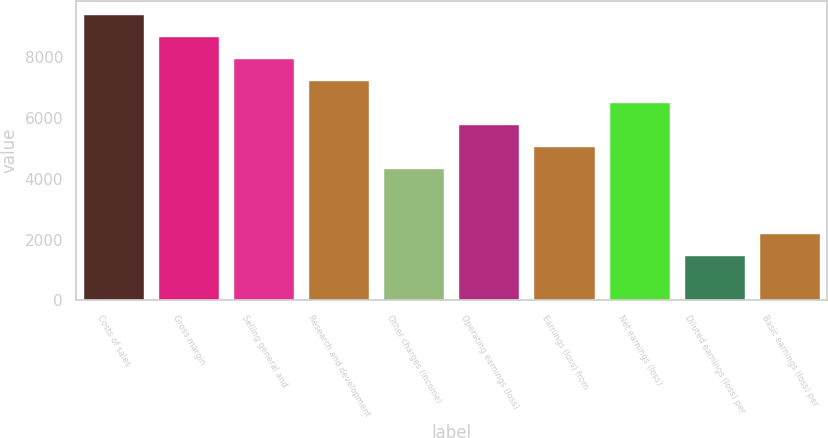<chart> <loc_0><loc_0><loc_500><loc_500><bar_chart><fcel>Costs of sales<fcel>Gross margin<fcel>Selling general and<fcel>Research and development<fcel>Other charges (income)<fcel>Operating earnings (loss)<fcel>Earnings (loss) from<fcel>Net earnings (loss)<fcel>Diluted earnings (loss) per<fcel>Basic earnings (loss) per<nl><fcel>9402.88<fcel>8679.58<fcel>7956.28<fcel>7232.99<fcel>4339.83<fcel>5786.41<fcel>5063.12<fcel>6509.7<fcel>1446.64<fcel>2169.94<nl></chart> 